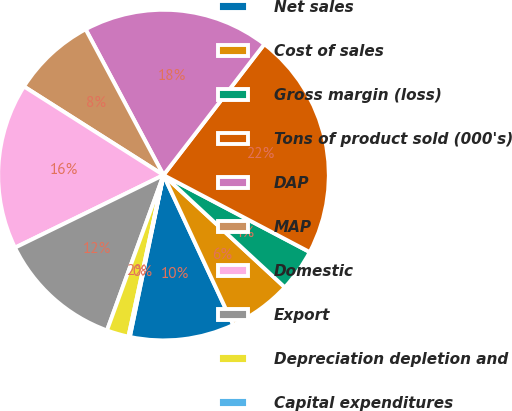Convert chart. <chart><loc_0><loc_0><loc_500><loc_500><pie_chart><fcel>Net sales<fcel>Cost of sales<fcel>Gross margin (loss)<fcel>Tons of product sold (000's)<fcel>DAP<fcel>MAP<fcel>Domestic<fcel>Export<fcel>Depreciation depletion and<fcel>Capital expenditures<nl><fcel>10.2%<fcel>6.18%<fcel>4.17%<fcel>22.27%<fcel>18.25%<fcel>8.19%<fcel>16.24%<fcel>12.21%<fcel>2.15%<fcel>0.14%<nl></chart> 